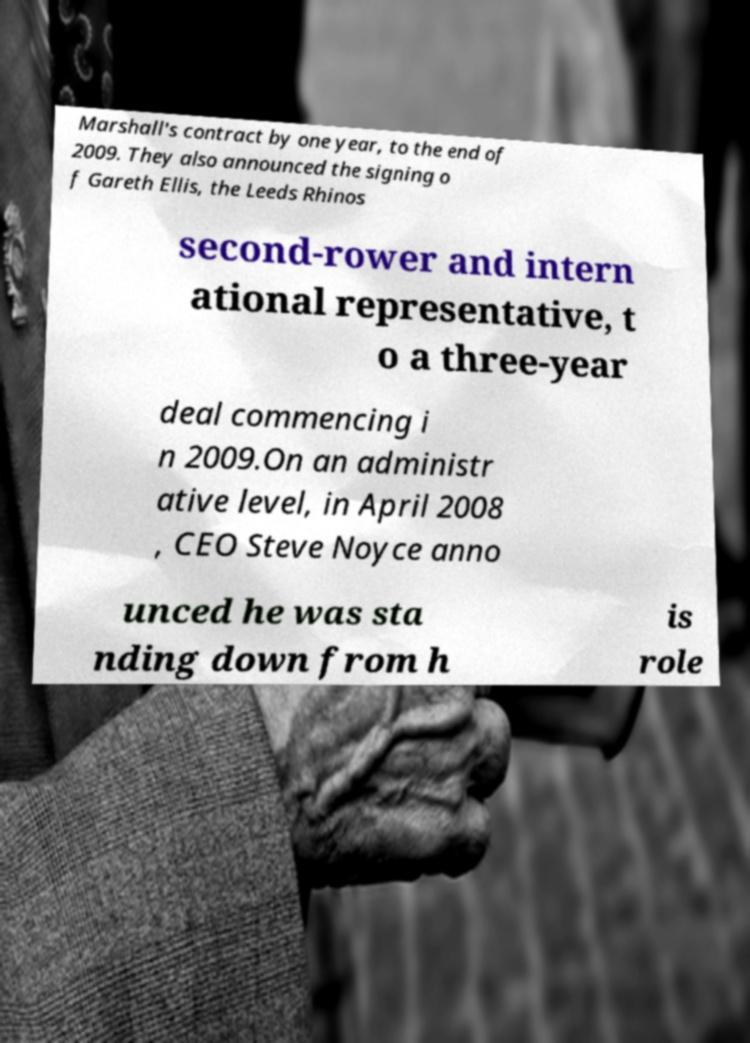Please read and relay the text visible in this image. What does it say? Marshall's contract by one year, to the end of 2009. They also announced the signing o f Gareth Ellis, the Leeds Rhinos second-rower and intern ational representative, t o a three-year deal commencing i n 2009.On an administr ative level, in April 2008 , CEO Steve Noyce anno unced he was sta nding down from h is role 